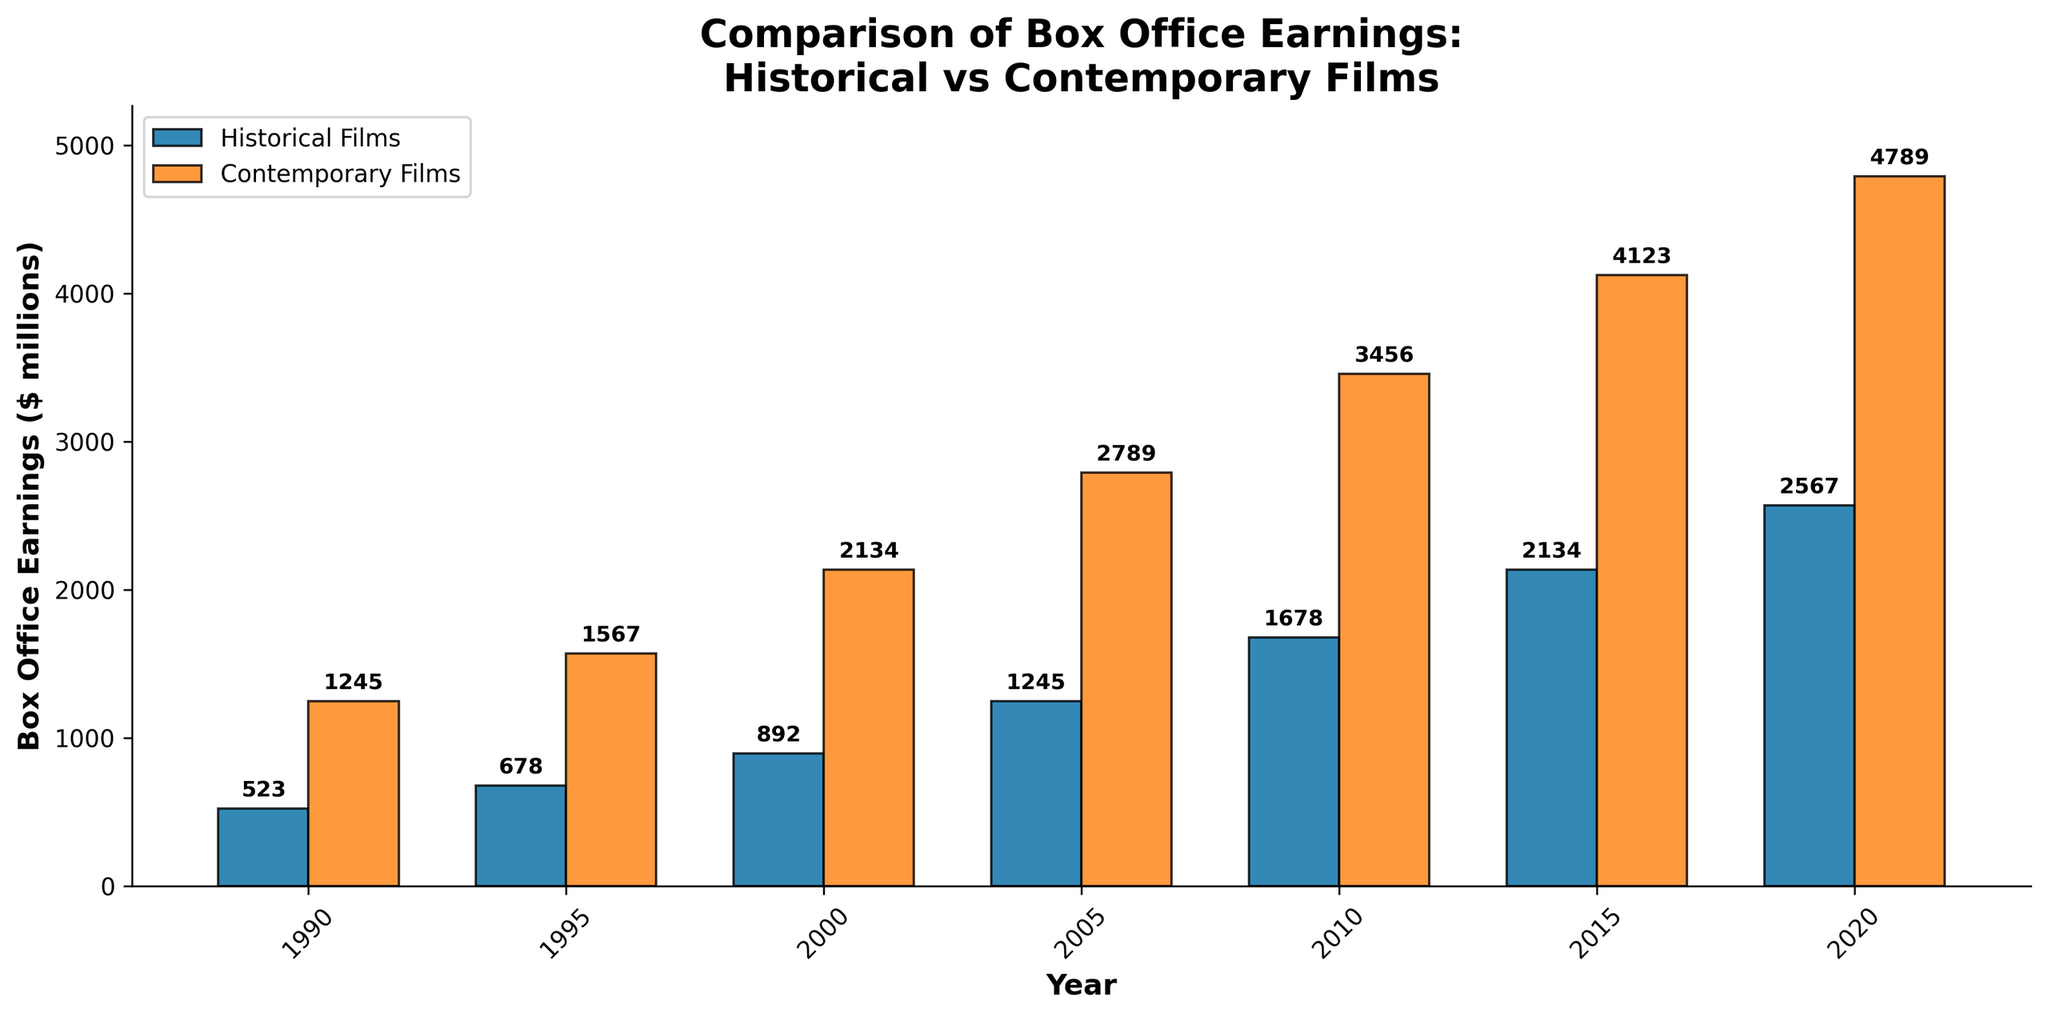What are the box office earnings for historical films in 2005? Look at the bar corresponding to the year 2005 and refer to the height of the historical films bar. The label on top of the bar indicates the value.
Answer: 1245 Which year saw the highest box office earnings for contemporary films, and what was the amount? Identify the tallest bar among the contemporary films and check the year and the label on top of the bar for the amount.
Answer: 2020, 4789 By how much did the box office earnings for contemporary films exceed historical films in 2015? Subtract the earnings of historical films from those of contemporary films for the year 2015 based on the labels on top of the bars.
Answer: 1989 What is the average box office earnings for historical films over the given period? Sum the box office earnings for historical films from 1990 to 2020 and then divide by the number of years (7). Calculation: (523 + 678 + 892 + 1245 + 1678 + 2134 + 2567) / 7 = 10717 / 7.
Answer: 1531 How did the box office earnings for historical films change from 1990 to 2000? Subtract the 1990 earnings from the 2000 earnings. Calculation: 892 - 523.
Answer: 369 During which year did the box office earnings for historical films first exceed 1000 million dollars? Identify the smallest year where the historical films bar exceeds 1000 million dollars and refer to the labels for the exact amount.
Answer: 2005 How much did the box office earnings for contemporary films increase from 1995 to 2010? Subtract the 1995 earnings from the 2010 earnings. Calculation: 3456 - 1567.
Answer: 1889 What is the trend in box office earnings for historical films from 1990 to 2020? Refer to the bar heights for historical films from 1990 to 2020, generally observing if the values are increasing, steady, or decreasing.
Answer: Increasing Which type of film had consistently higher box office earnings throughout the entire period? Compare the heights of the bars for historical and contemporary films for each year.
Answer: Contemporary films 